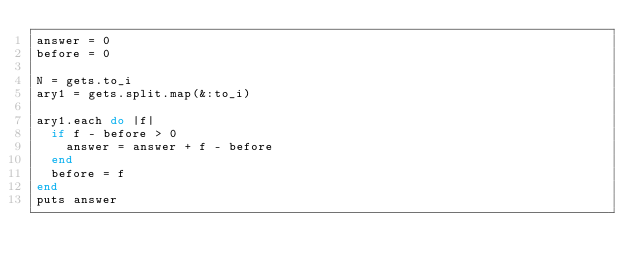Convert code to text. <code><loc_0><loc_0><loc_500><loc_500><_Ruby_>answer = 0
before = 0

N = gets.to_i
ary1 = gets.split.map(&:to_i)

ary1.each do |f|
  if f - before > 0
    answer = answer + f - before
  end
  before = f
end
puts answer</code> 